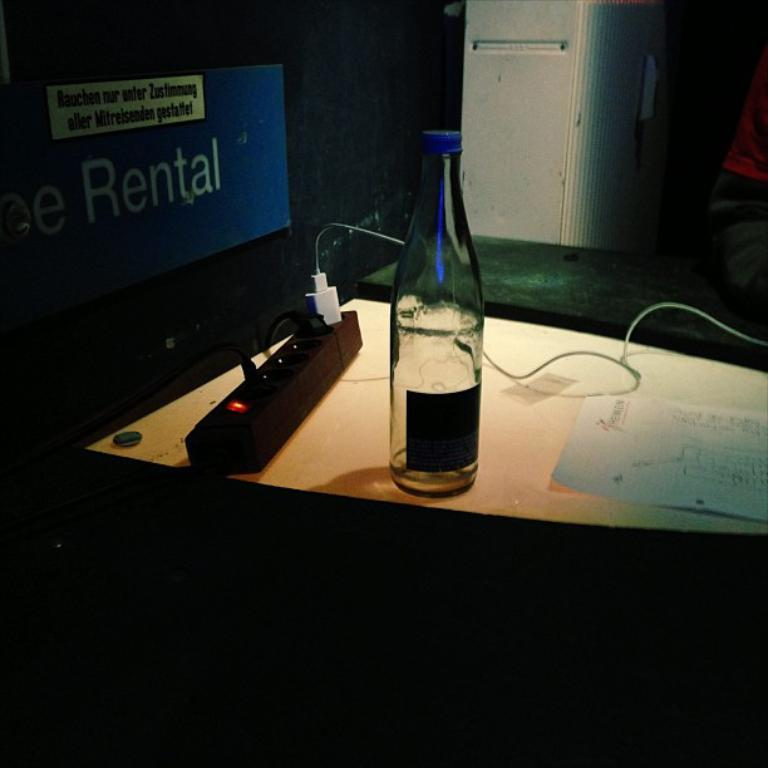<image>
Describe the image concisely. A dark room with a blue electronic screen in the background displaying the word Rental. 